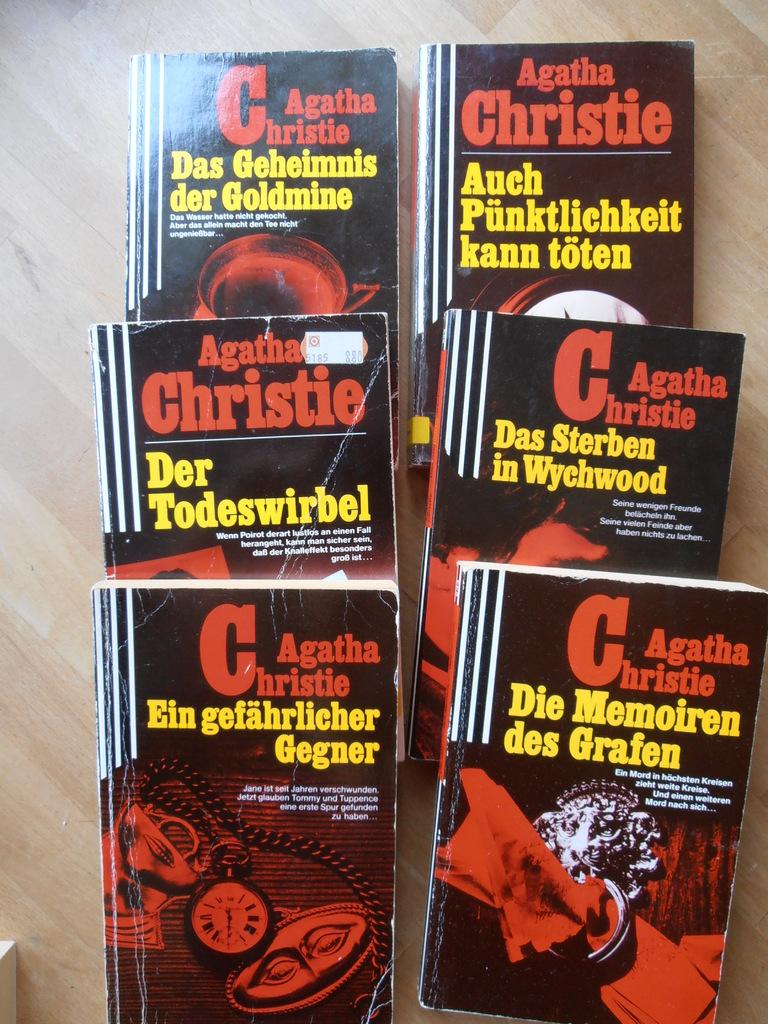Who wrote these novels?
Give a very brief answer. Agatha christie. 